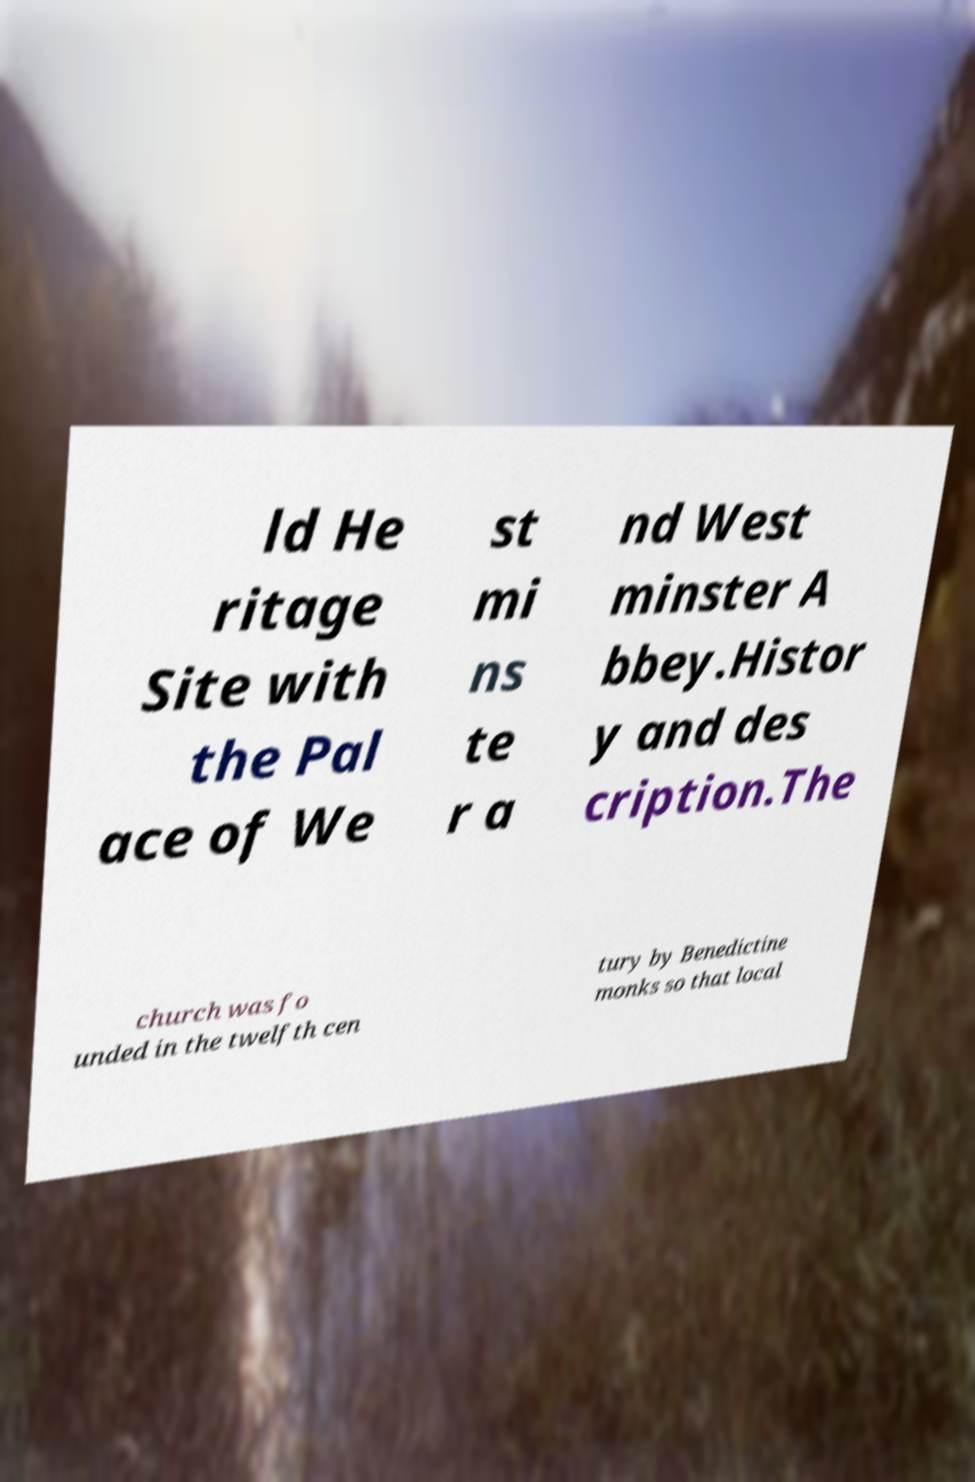I need the written content from this picture converted into text. Can you do that? ld He ritage Site with the Pal ace of We st mi ns te r a nd West minster A bbey.Histor y and des cription.The church was fo unded in the twelfth cen tury by Benedictine monks so that local 